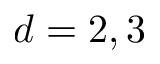Convert formula to latex. <formula><loc_0><loc_0><loc_500><loc_500>d = 2 , 3</formula> 